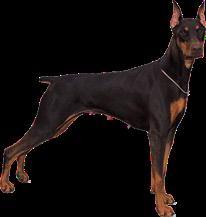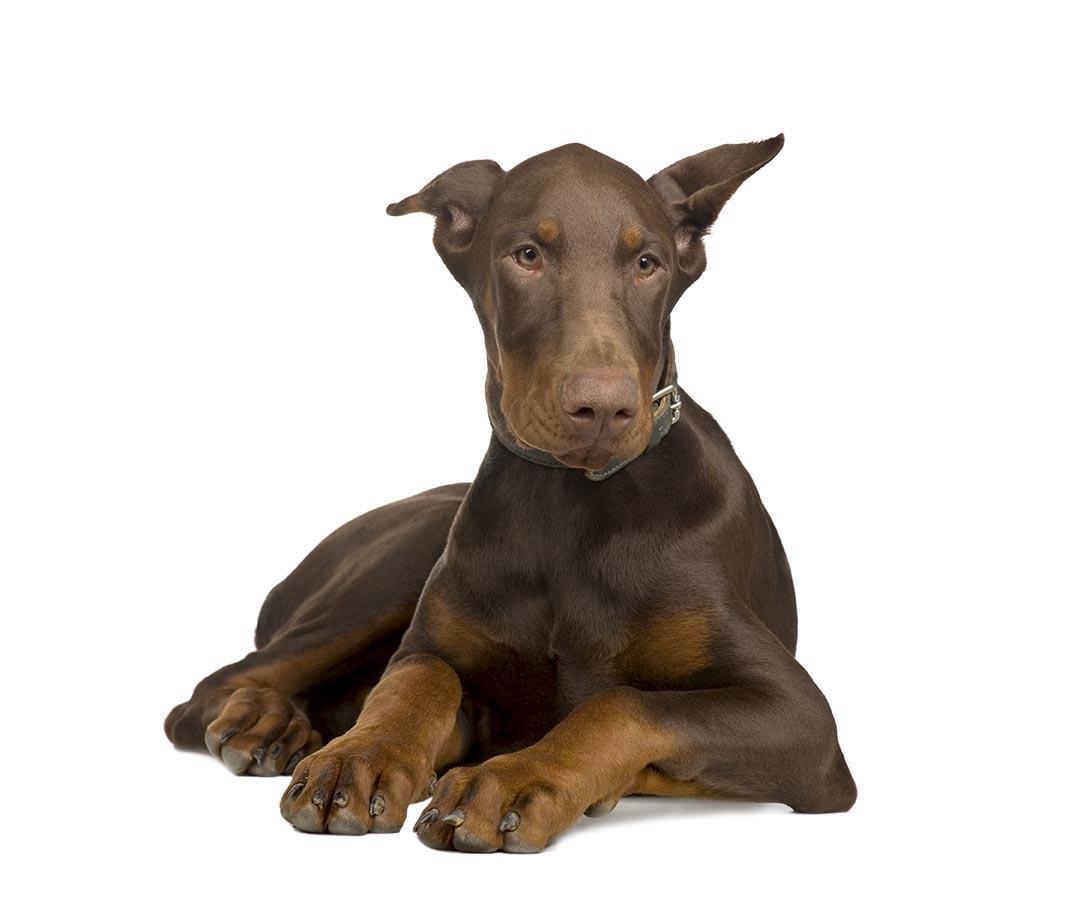The first image is the image on the left, the second image is the image on the right. For the images shown, is this caption "One image shows a forward-facing brown-and-tan doberman, with its front paws extended forward." true? Answer yes or no. Yes. 